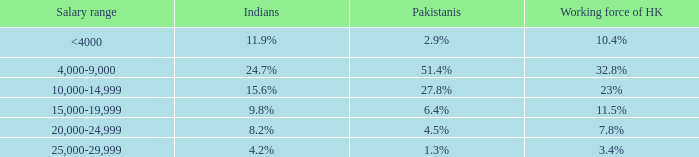2%, what is the earnings range? 20,000-24,999. 